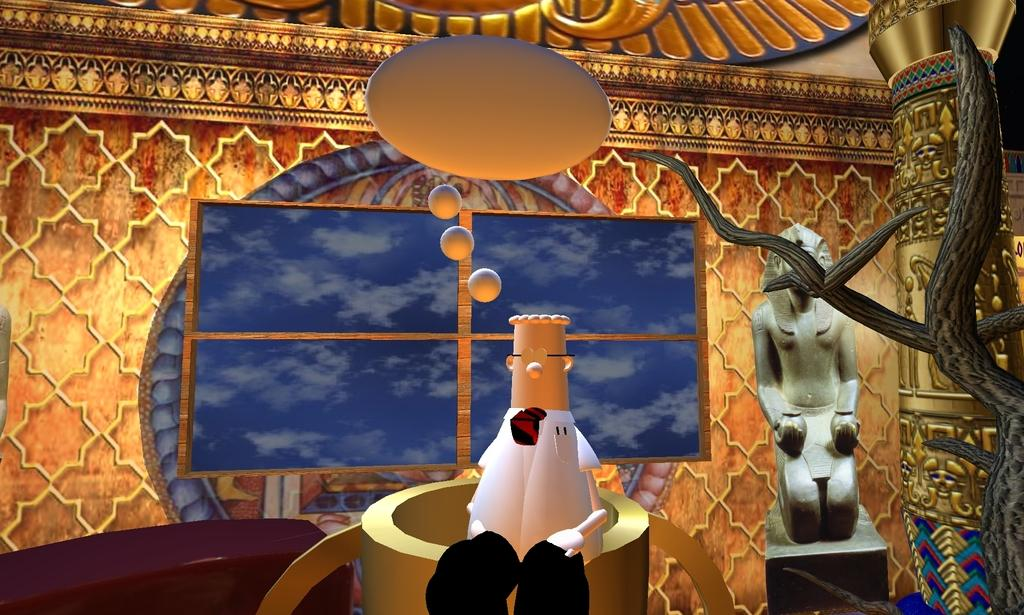What type of image is depicted in the picture? There is a cartoon picture in the image. What other objects or structures can be seen in the image? There is a statue, a tree, a wall in the background, and a window in the image. What type of comb is being used by the government in the image? There is no mention of a comb or the government in the image; it features a cartoon picture, a statue, a tree, a wall, and a window. 